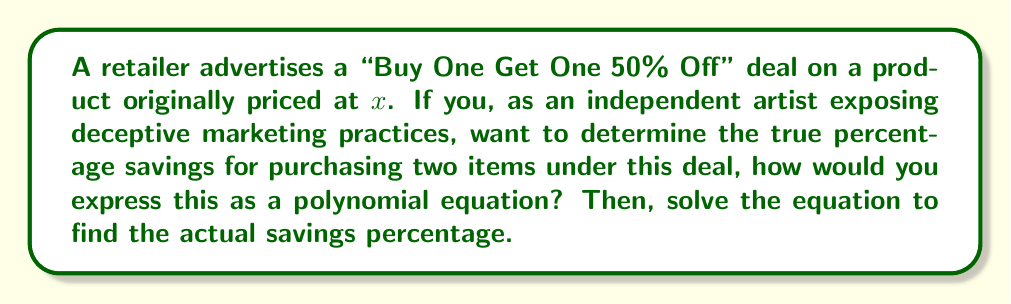Show me your answer to this math problem. Let's approach this step-by-step:

1) First, let's calculate the cost of buying two items under this deal:
   - First item: $x$
   - Second item: $0.5x$ (50% off)
   Total cost: $x + 0.5x = 1.5x$

2) Now, let's calculate what two items would cost without the deal:
   $2x$

3) The savings can be expressed as:
   $2x - 1.5x = 0.5x$

4) To calculate the percentage savings, we divide the savings by the original price and multiply by 100:
   $$\text{Percentage Savings} = \frac{0.5x}{2x} \times 100$$

5) Simplify the fraction:
   $$\frac{0.5x}{2x} = \frac{1}{4} = 0.25$$

6) Multiply by 100 to get the percentage:
   $$0.25 \times 100 = 25\%$$

This shows that the actual savings is 25%, not 50% as the marketing might lead customers to believe.

7) To express this as a polynomial equation:
   Let $y$ be the percentage savings
   $$y = \frac{2x - 1.5x}{2x} \times 100$$
   $$y = \frac{0.5x}{2x} \times 100$$
   $$y = 25$$

This polynomial equation simplifies to a constant, showing that the savings percentage is independent of the original price $x$.
Answer: 25% 